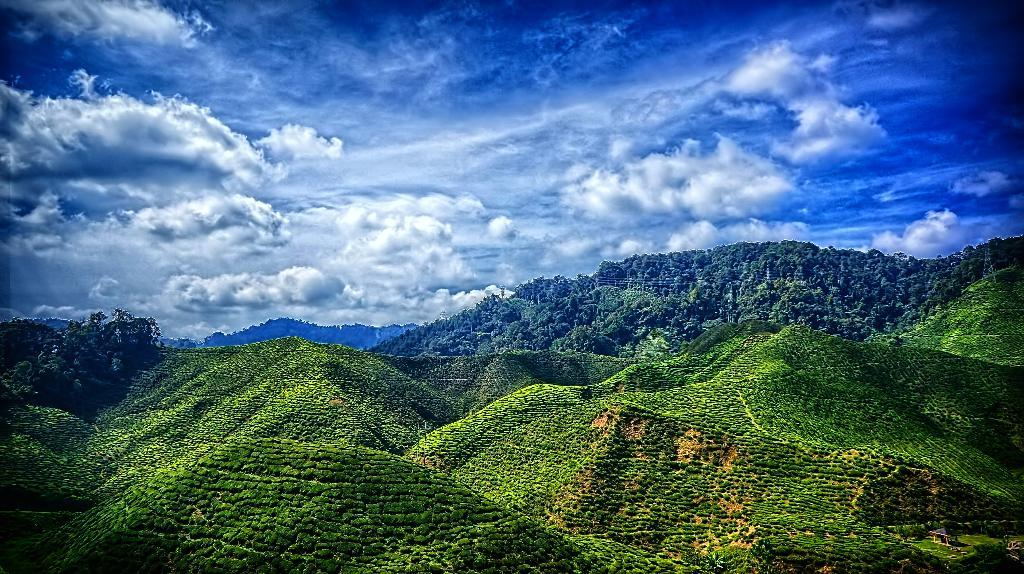What type of landscape can be seen in the image? There are hills in the image. What can be found on the hills? Trees are present on the hills. How would you describe the sky in the image? The sky is blue and cloudy in the image. What type of farm animals can be seen grazing on the hills in the image? There are no farm animals present in the image; it only features hills with trees. How are the people in the image transporting themselves around the hills? There are no people present in the image, so it is not possible to determine how they would be transporting themselves. 